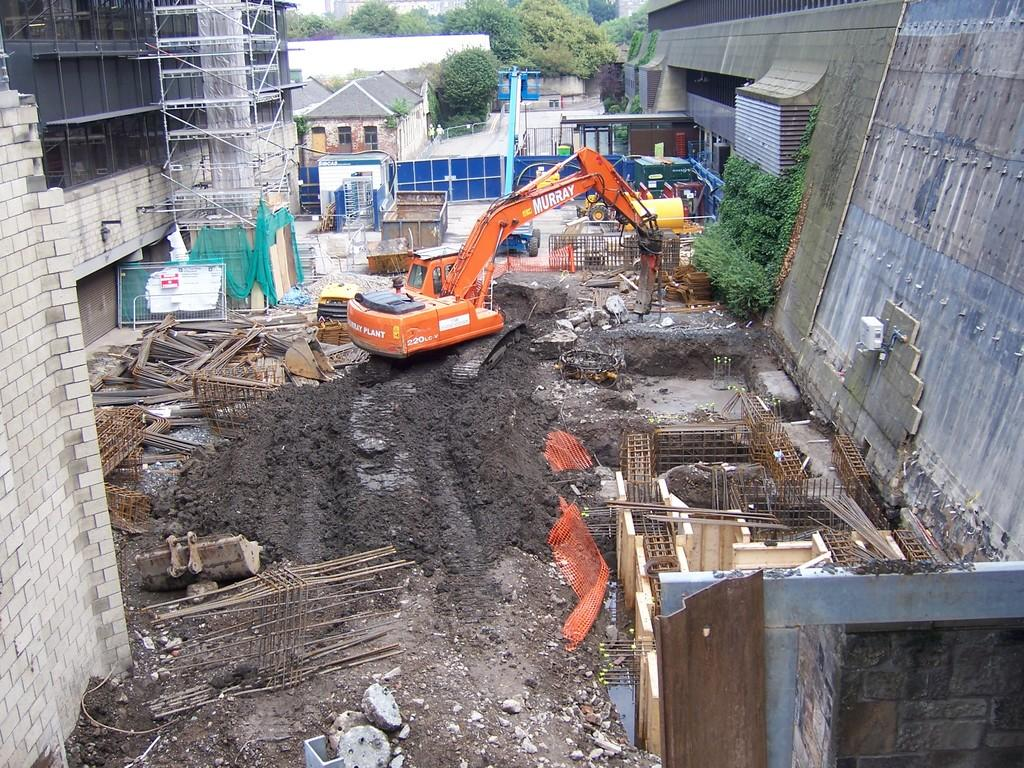What is located on the left side of the image? There is a wall on the left side of the image. What is the main subject in the middle of the image? There is a vehicle in the middle of the image. What is on the right side of the image? There is another wall on the right side of the image. What can be seen in the background of the image? There are trees and houses visible in the background of the image. Can you tell me how many snakes are crawling on the wall in the image? There are no snakes present in the image; it features walls, a vehicle, trees, and houses. What type of field is visible in the background of the image? There is no field visible in the background of the image; it features trees and houses. 